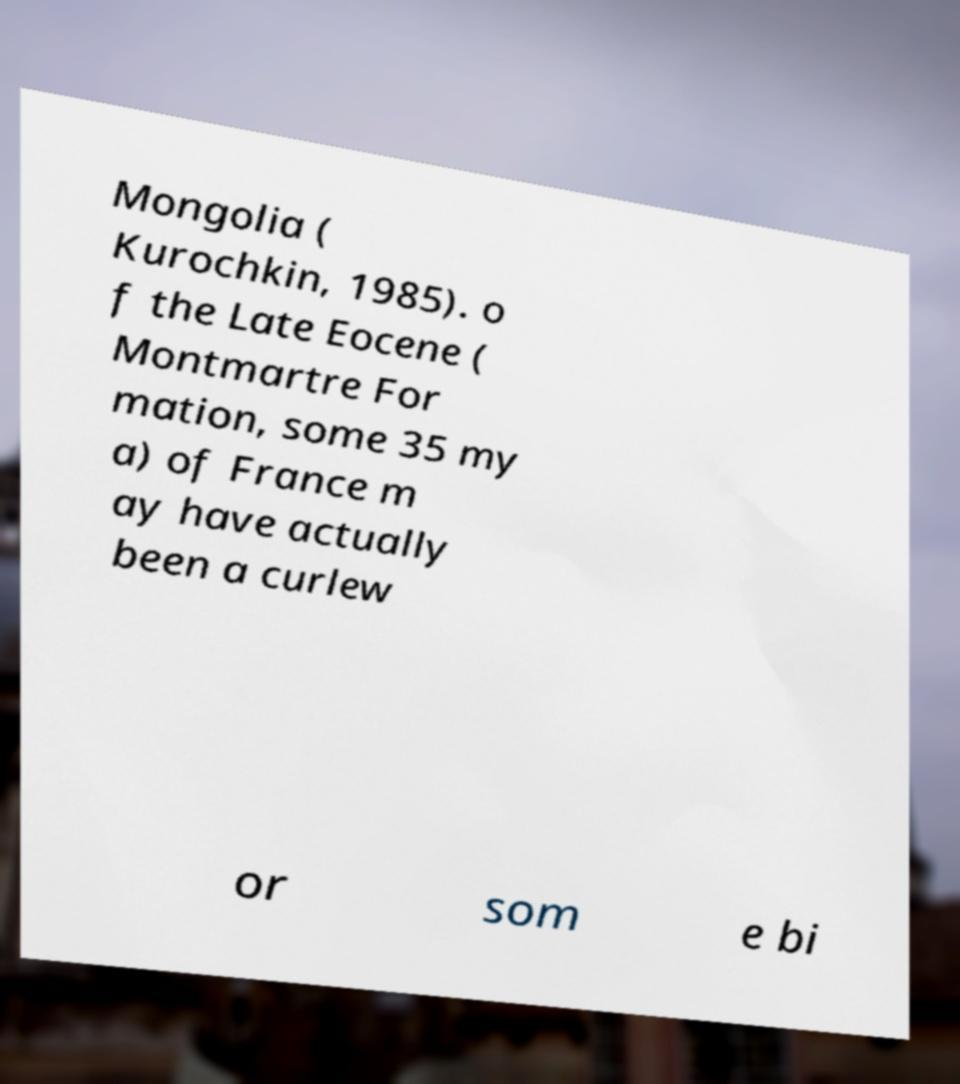Can you read and provide the text displayed in the image?This photo seems to have some interesting text. Can you extract and type it out for me? Mongolia ( Kurochkin, 1985). o f the Late Eocene ( Montmartre For mation, some 35 my a) of France m ay have actually been a curlew or som e bi 